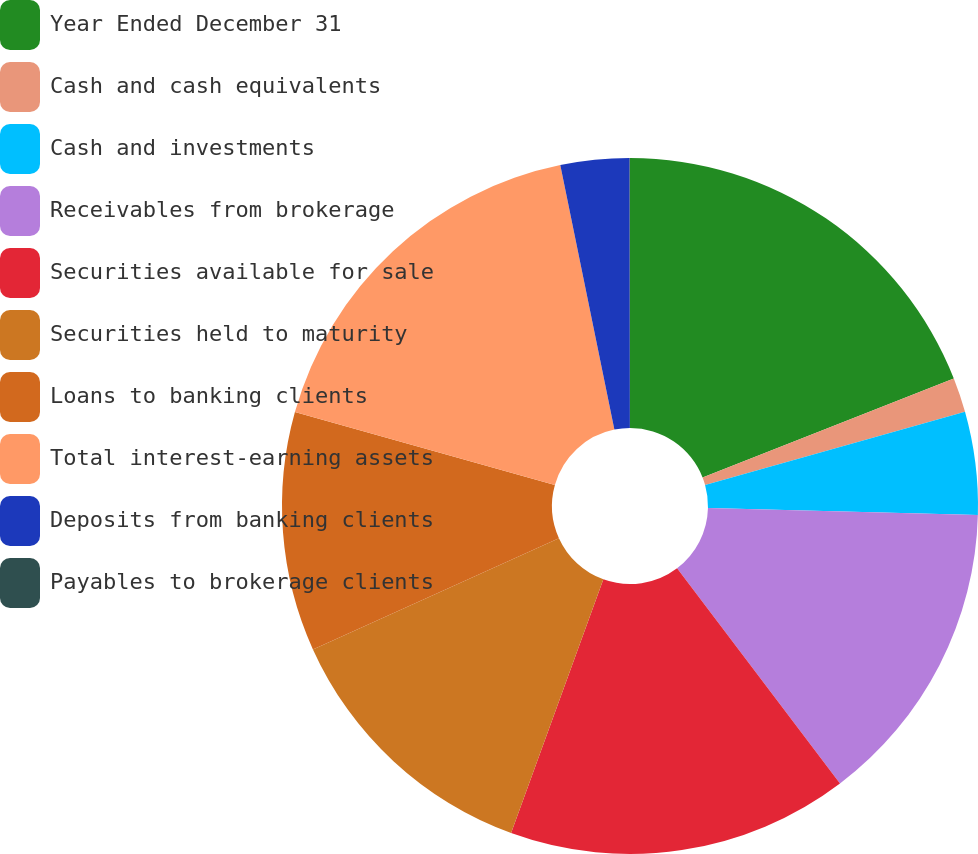Convert chart to OTSL. <chart><loc_0><loc_0><loc_500><loc_500><pie_chart><fcel>Year Ended December 31<fcel>Cash and cash equivalents<fcel>Cash and investments<fcel>Receivables from brokerage<fcel>Securities available for sale<fcel>Securities held to maturity<fcel>Loans to banking clients<fcel>Total interest-earning assets<fcel>Deposits from banking clients<fcel>Payables to brokerage clients<nl><fcel>19.03%<fcel>1.61%<fcel>4.77%<fcel>14.28%<fcel>15.86%<fcel>12.69%<fcel>11.11%<fcel>17.44%<fcel>3.19%<fcel>0.02%<nl></chart> 